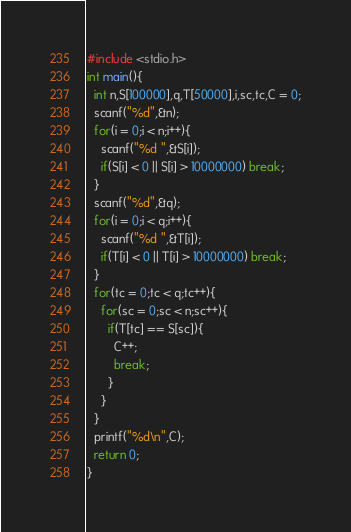Convert code to text. <code><loc_0><loc_0><loc_500><loc_500><_C_>#include <stdio.h>
int main(){
  int n,S[100000],q,T[50000],i,sc,tc,C = 0;
  scanf("%d",&n);
  for(i = 0;i < n;i++){
    scanf("%d ",&S[i]);
    if(S[i] < 0 || S[i] > 10000000) break;
  }
  scanf("%d",&q);
  for(i = 0;i < q;i++){
    scanf("%d ",&T[i]);
    if(T[i] < 0 || T[i] > 10000000) break;
  }
  for(tc = 0;tc < q;tc++){
    for(sc = 0;sc < n;sc++){
      if(T[tc] == S[sc]){
        C++;
        break;
      }
    }
  }
  printf("%d\n",C);
  return 0;
}</code> 